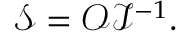Convert formula to latex. <formula><loc_0><loc_0><loc_500><loc_500>\mathcal { S } = \mathcal { O } \mathcal { I } ^ { - 1 } .</formula> 